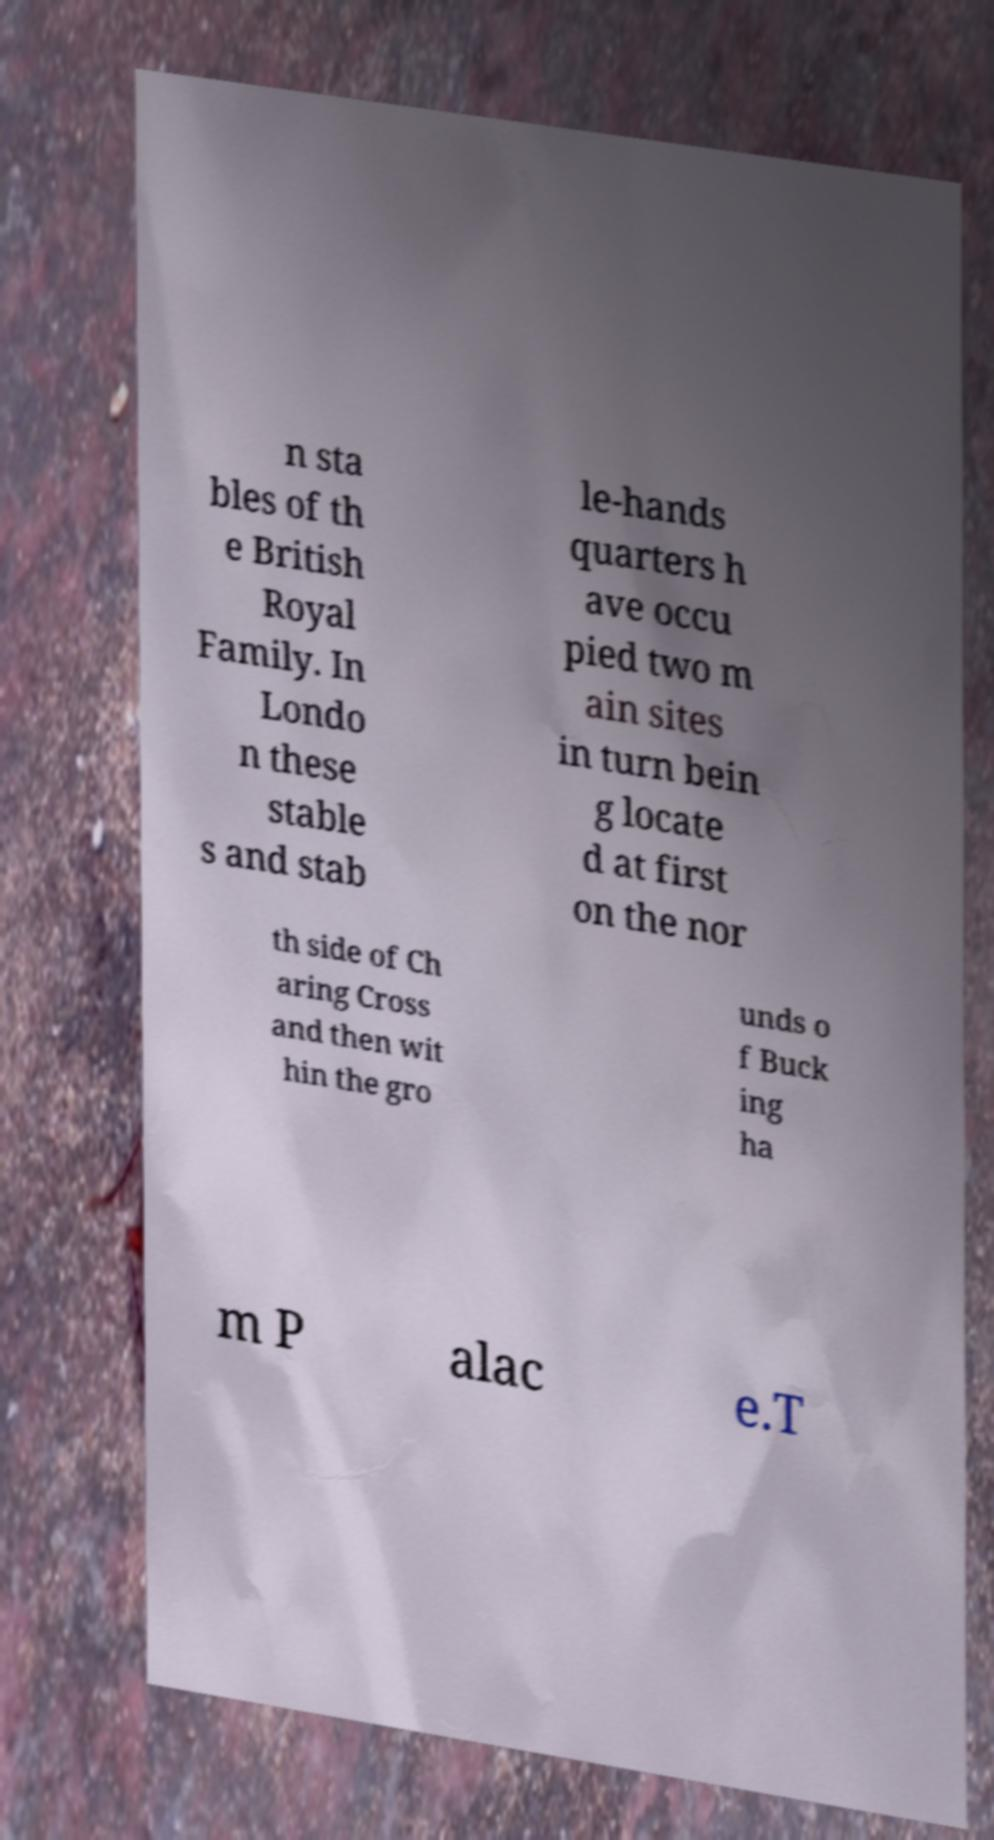What messages or text are displayed in this image? I need them in a readable, typed format. n sta bles of th e British Royal Family. In Londo n these stable s and stab le-hands quarters h ave occu pied two m ain sites in turn bein g locate d at first on the nor th side of Ch aring Cross and then wit hin the gro unds o f Buck ing ha m P alac e.T 